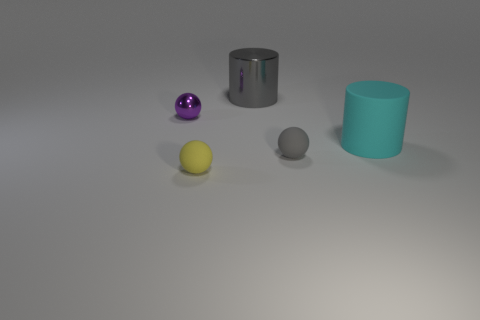How many small brown cubes are the same material as the cyan object?
Give a very brief answer. 0. There is a big rubber cylinder; is its color the same as the big cylinder behind the cyan thing?
Your answer should be compact. No. What number of small purple shiny spheres are there?
Keep it short and to the point. 1. Is there a tiny metal ball of the same color as the large metal cylinder?
Keep it short and to the point. No. The cylinder to the left of the cylinder that is in front of the tiny purple shiny thing that is behind the gray ball is what color?
Your answer should be very brief. Gray. Is the material of the small purple object the same as the small object on the right side of the metallic cylinder?
Offer a very short reply. No. What material is the large cyan object?
Provide a succinct answer. Rubber. There is a small object that is the same color as the shiny cylinder; what material is it?
Keep it short and to the point. Rubber. How many other objects are there of the same material as the yellow thing?
Keep it short and to the point. 2. The rubber thing that is to the left of the large cyan thing and on the right side of the small yellow ball has what shape?
Offer a very short reply. Sphere. 